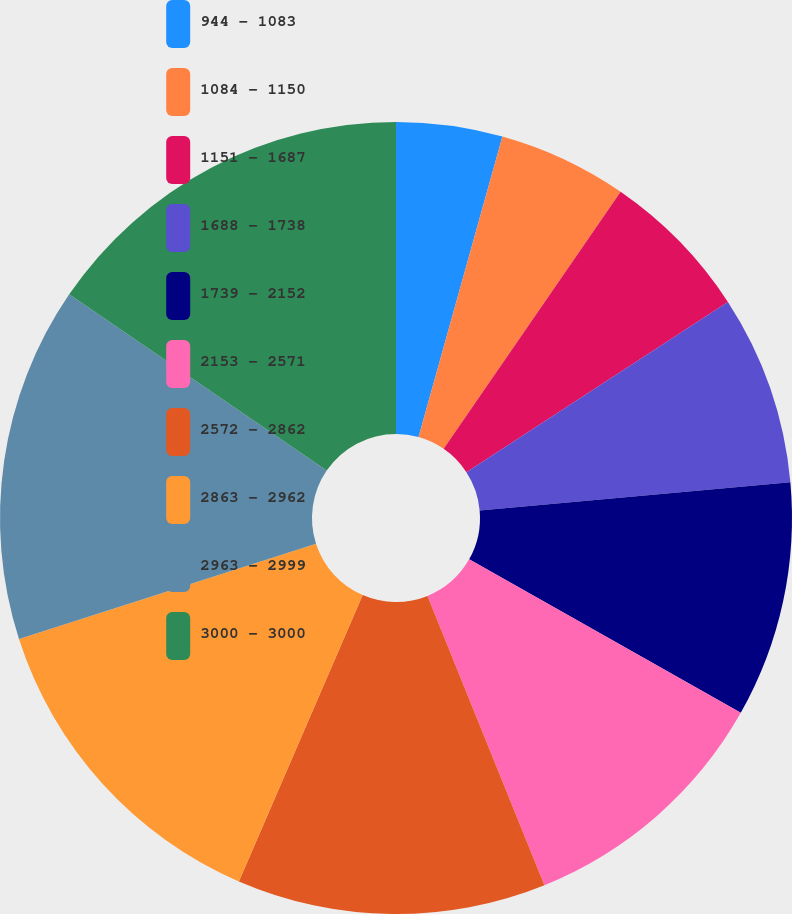<chart> <loc_0><loc_0><loc_500><loc_500><pie_chart><fcel>944 - 1083<fcel>1084 - 1150<fcel>1151 - 1687<fcel>1688 - 1738<fcel>1739 - 2152<fcel>2153 - 2571<fcel>2572 - 2862<fcel>2863 - 2962<fcel>2963 - 2999<fcel>3000 - 3000<nl><fcel>4.33%<fcel>5.27%<fcel>6.22%<fcel>7.74%<fcel>9.63%<fcel>10.7%<fcel>12.61%<fcel>13.56%<fcel>14.5%<fcel>15.45%<nl></chart> 